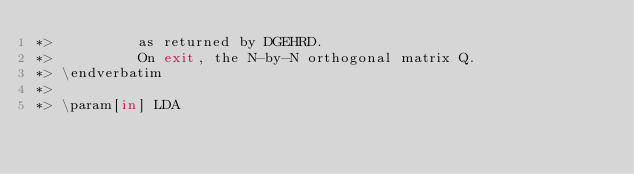<code> <loc_0><loc_0><loc_500><loc_500><_FORTRAN_>*>          as returned by DGEHRD.
*>          On exit, the N-by-N orthogonal matrix Q.
*> \endverbatim
*>
*> \param[in] LDA</code> 